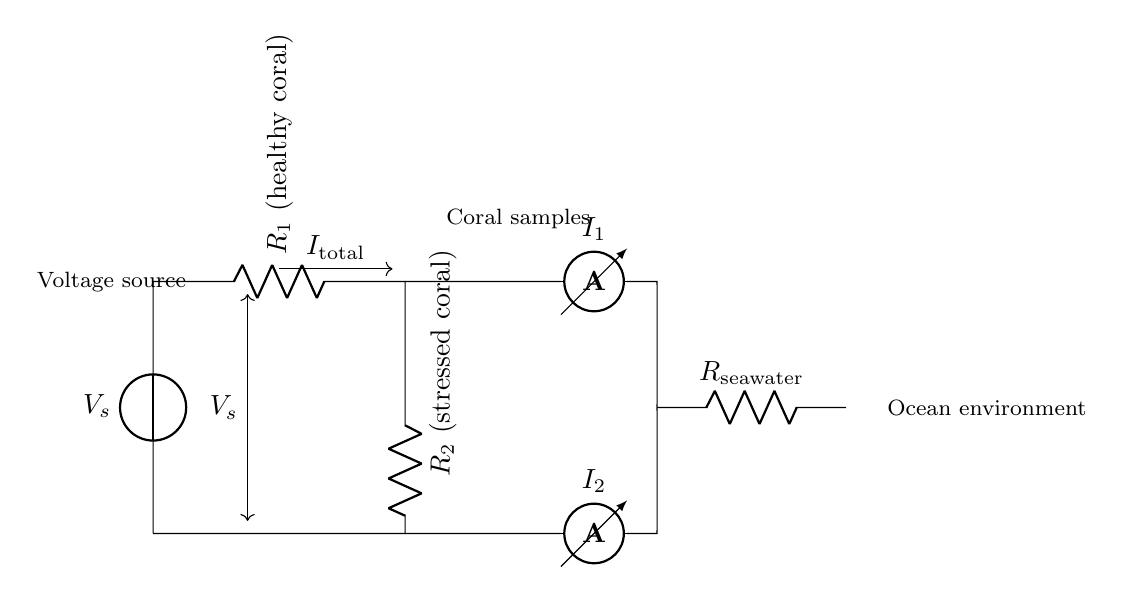What does R1 represent in the circuit? R1 represents healthy coral within the coral reef ecosystem. It has a specific resistance that indicates the electrical conductivity of healthy coral.
Answer: healthy coral What is the role of R2 in this configuration? R2 represents stressed coral, indicating how its conductivity changes due to environmental stress factors compared to healthy coral.
Answer: stressed coral What does Ammeter I1 measure? I1 measures the current flowing through the circuit associated with healthy coral, providing insights into its electrical conductivity.
Answer: current in healthy coral How does the voltage source affect this circuit? The voltage source provides a constant potential difference, which drives the current through both R1 and R2, essential for analyzing electrical conductivity under different conditions.
Answer: drives current What can be inferred about the overall health of the coral reef ecosystem if R2 has a significantly higher resistance than R1? If R2 has higher resistance, it indicates that the stressed coral is less conductive, suggesting unfavorable conditions or damage affecting the ecosystem's health.
Answer: unfavorable conditions What is the significance of the seawater resistor R_seawater in this analysis? R_seawater represents the impedance of the ocean environment, affecting current flow through the corals and crucial for understanding the complete circuit behavior in a marine ecosystem.
Answer: ocean impedance What type of circuit configuration is shown here? The circuit is a current divider, designed to analyze how current is shared between two resistive paths (healthy and stressed coral).
Answer: current divider 